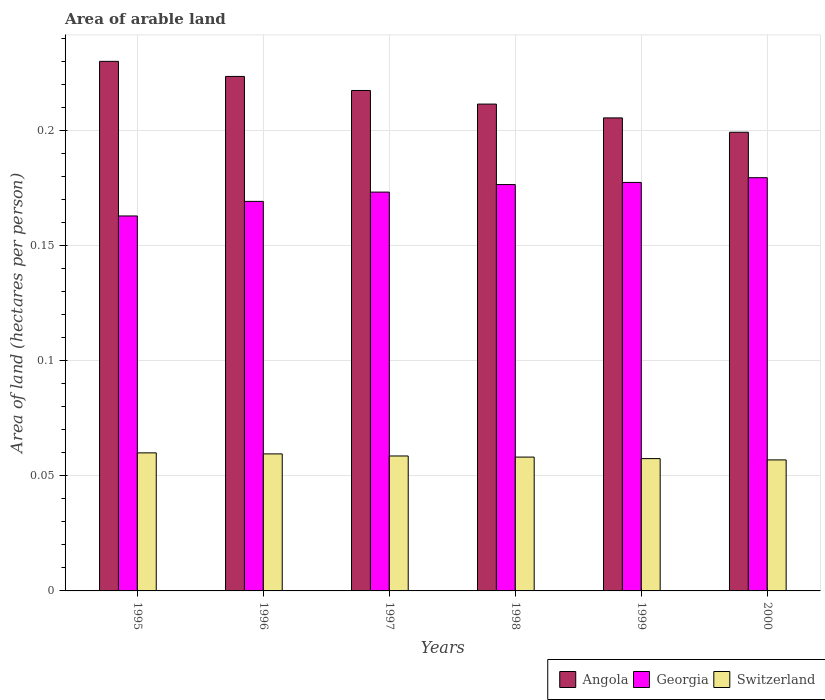How many different coloured bars are there?
Your response must be concise. 3. Are the number of bars on each tick of the X-axis equal?
Keep it short and to the point. Yes. How many bars are there on the 4th tick from the right?
Your answer should be very brief. 3. What is the label of the 1st group of bars from the left?
Offer a very short reply. 1995. What is the total arable land in Angola in 1996?
Offer a terse response. 0.22. Across all years, what is the maximum total arable land in Georgia?
Keep it short and to the point. 0.18. Across all years, what is the minimum total arable land in Angola?
Keep it short and to the point. 0.2. In which year was the total arable land in Switzerland maximum?
Your answer should be compact. 1995. In which year was the total arable land in Georgia minimum?
Make the answer very short. 1995. What is the total total arable land in Angola in the graph?
Give a very brief answer. 1.29. What is the difference between the total arable land in Angola in 1996 and that in 1997?
Make the answer very short. 0.01. What is the difference between the total arable land in Switzerland in 2000 and the total arable land in Angola in 1997?
Ensure brevity in your answer.  -0.16. What is the average total arable land in Switzerland per year?
Keep it short and to the point. 0.06. In the year 1997, what is the difference between the total arable land in Switzerland and total arable land in Georgia?
Your answer should be compact. -0.11. In how many years, is the total arable land in Angola greater than 0.2 hectares per person?
Offer a terse response. 5. What is the ratio of the total arable land in Angola in 1997 to that in 1999?
Give a very brief answer. 1.06. What is the difference between the highest and the second highest total arable land in Angola?
Give a very brief answer. 0.01. What is the difference between the highest and the lowest total arable land in Georgia?
Ensure brevity in your answer.  0.02. Is the sum of the total arable land in Angola in 1998 and 2000 greater than the maximum total arable land in Georgia across all years?
Give a very brief answer. Yes. What does the 3rd bar from the left in 1998 represents?
Provide a short and direct response. Switzerland. What does the 3rd bar from the right in 1998 represents?
Provide a succinct answer. Angola. Are all the bars in the graph horizontal?
Your response must be concise. No. How many years are there in the graph?
Offer a very short reply. 6. Does the graph contain any zero values?
Make the answer very short. No. Does the graph contain grids?
Keep it short and to the point. Yes. Where does the legend appear in the graph?
Offer a very short reply. Bottom right. What is the title of the graph?
Ensure brevity in your answer.  Area of arable land. Does "Curacao" appear as one of the legend labels in the graph?
Keep it short and to the point. No. What is the label or title of the Y-axis?
Your response must be concise. Area of land (hectares per person). What is the Area of land (hectares per person) in Angola in 1995?
Make the answer very short. 0.23. What is the Area of land (hectares per person) in Georgia in 1995?
Keep it short and to the point. 0.16. What is the Area of land (hectares per person) in Switzerland in 1995?
Make the answer very short. 0.06. What is the Area of land (hectares per person) of Angola in 1996?
Keep it short and to the point. 0.22. What is the Area of land (hectares per person) in Georgia in 1996?
Your answer should be compact. 0.17. What is the Area of land (hectares per person) in Switzerland in 1996?
Provide a short and direct response. 0.06. What is the Area of land (hectares per person) in Angola in 1997?
Ensure brevity in your answer.  0.22. What is the Area of land (hectares per person) in Georgia in 1997?
Offer a very short reply. 0.17. What is the Area of land (hectares per person) of Switzerland in 1997?
Provide a short and direct response. 0.06. What is the Area of land (hectares per person) of Angola in 1998?
Keep it short and to the point. 0.21. What is the Area of land (hectares per person) in Georgia in 1998?
Keep it short and to the point. 0.18. What is the Area of land (hectares per person) in Switzerland in 1998?
Make the answer very short. 0.06. What is the Area of land (hectares per person) in Angola in 1999?
Ensure brevity in your answer.  0.21. What is the Area of land (hectares per person) of Georgia in 1999?
Give a very brief answer. 0.18. What is the Area of land (hectares per person) of Switzerland in 1999?
Your answer should be very brief. 0.06. What is the Area of land (hectares per person) of Angola in 2000?
Offer a very short reply. 0.2. What is the Area of land (hectares per person) in Georgia in 2000?
Make the answer very short. 0.18. What is the Area of land (hectares per person) in Switzerland in 2000?
Offer a terse response. 0.06. Across all years, what is the maximum Area of land (hectares per person) of Angola?
Make the answer very short. 0.23. Across all years, what is the maximum Area of land (hectares per person) in Georgia?
Your answer should be very brief. 0.18. Across all years, what is the maximum Area of land (hectares per person) in Switzerland?
Make the answer very short. 0.06. Across all years, what is the minimum Area of land (hectares per person) of Angola?
Provide a succinct answer. 0.2. Across all years, what is the minimum Area of land (hectares per person) of Georgia?
Give a very brief answer. 0.16. Across all years, what is the minimum Area of land (hectares per person) in Switzerland?
Your answer should be very brief. 0.06. What is the total Area of land (hectares per person) in Angola in the graph?
Give a very brief answer. 1.29. What is the total Area of land (hectares per person) of Georgia in the graph?
Give a very brief answer. 1.04. What is the total Area of land (hectares per person) in Switzerland in the graph?
Your answer should be very brief. 0.35. What is the difference between the Area of land (hectares per person) in Angola in 1995 and that in 1996?
Give a very brief answer. 0.01. What is the difference between the Area of land (hectares per person) of Georgia in 1995 and that in 1996?
Provide a short and direct response. -0.01. What is the difference between the Area of land (hectares per person) of Switzerland in 1995 and that in 1996?
Make the answer very short. 0. What is the difference between the Area of land (hectares per person) of Angola in 1995 and that in 1997?
Keep it short and to the point. 0.01. What is the difference between the Area of land (hectares per person) in Georgia in 1995 and that in 1997?
Give a very brief answer. -0.01. What is the difference between the Area of land (hectares per person) in Switzerland in 1995 and that in 1997?
Your answer should be compact. 0. What is the difference between the Area of land (hectares per person) in Angola in 1995 and that in 1998?
Give a very brief answer. 0.02. What is the difference between the Area of land (hectares per person) of Georgia in 1995 and that in 1998?
Offer a terse response. -0.01. What is the difference between the Area of land (hectares per person) of Switzerland in 1995 and that in 1998?
Offer a terse response. 0. What is the difference between the Area of land (hectares per person) of Angola in 1995 and that in 1999?
Keep it short and to the point. 0.02. What is the difference between the Area of land (hectares per person) of Georgia in 1995 and that in 1999?
Make the answer very short. -0.01. What is the difference between the Area of land (hectares per person) of Switzerland in 1995 and that in 1999?
Your answer should be very brief. 0. What is the difference between the Area of land (hectares per person) in Angola in 1995 and that in 2000?
Ensure brevity in your answer.  0.03. What is the difference between the Area of land (hectares per person) of Georgia in 1995 and that in 2000?
Make the answer very short. -0.02. What is the difference between the Area of land (hectares per person) of Switzerland in 1995 and that in 2000?
Make the answer very short. 0. What is the difference between the Area of land (hectares per person) in Angola in 1996 and that in 1997?
Ensure brevity in your answer.  0.01. What is the difference between the Area of land (hectares per person) in Georgia in 1996 and that in 1997?
Offer a terse response. -0. What is the difference between the Area of land (hectares per person) in Switzerland in 1996 and that in 1997?
Offer a very short reply. 0. What is the difference between the Area of land (hectares per person) of Angola in 1996 and that in 1998?
Ensure brevity in your answer.  0.01. What is the difference between the Area of land (hectares per person) of Georgia in 1996 and that in 1998?
Your response must be concise. -0.01. What is the difference between the Area of land (hectares per person) of Switzerland in 1996 and that in 1998?
Make the answer very short. 0. What is the difference between the Area of land (hectares per person) in Angola in 1996 and that in 1999?
Your response must be concise. 0.02. What is the difference between the Area of land (hectares per person) of Georgia in 1996 and that in 1999?
Offer a terse response. -0.01. What is the difference between the Area of land (hectares per person) in Switzerland in 1996 and that in 1999?
Your response must be concise. 0. What is the difference between the Area of land (hectares per person) in Angola in 1996 and that in 2000?
Your response must be concise. 0.02. What is the difference between the Area of land (hectares per person) of Georgia in 1996 and that in 2000?
Provide a short and direct response. -0.01. What is the difference between the Area of land (hectares per person) in Switzerland in 1996 and that in 2000?
Give a very brief answer. 0. What is the difference between the Area of land (hectares per person) in Angola in 1997 and that in 1998?
Your response must be concise. 0.01. What is the difference between the Area of land (hectares per person) of Georgia in 1997 and that in 1998?
Provide a short and direct response. -0. What is the difference between the Area of land (hectares per person) in Angola in 1997 and that in 1999?
Your response must be concise. 0.01. What is the difference between the Area of land (hectares per person) of Georgia in 1997 and that in 1999?
Keep it short and to the point. -0. What is the difference between the Area of land (hectares per person) in Switzerland in 1997 and that in 1999?
Offer a terse response. 0. What is the difference between the Area of land (hectares per person) in Angola in 1997 and that in 2000?
Offer a very short reply. 0.02. What is the difference between the Area of land (hectares per person) in Georgia in 1997 and that in 2000?
Provide a succinct answer. -0.01. What is the difference between the Area of land (hectares per person) in Switzerland in 1997 and that in 2000?
Provide a short and direct response. 0. What is the difference between the Area of land (hectares per person) of Angola in 1998 and that in 1999?
Give a very brief answer. 0.01. What is the difference between the Area of land (hectares per person) in Georgia in 1998 and that in 1999?
Offer a very short reply. -0. What is the difference between the Area of land (hectares per person) in Switzerland in 1998 and that in 1999?
Your answer should be very brief. 0. What is the difference between the Area of land (hectares per person) in Angola in 1998 and that in 2000?
Your response must be concise. 0.01. What is the difference between the Area of land (hectares per person) in Georgia in 1998 and that in 2000?
Ensure brevity in your answer.  -0. What is the difference between the Area of land (hectares per person) in Switzerland in 1998 and that in 2000?
Give a very brief answer. 0. What is the difference between the Area of land (hectares per person) in Angola in 1999 and that in 2000?
Provide a succinct answer. 0.01. What is the difference between the Area of land (hectares per person) of Georgia in 1999 and that in 2000?
Provide a succinct answer. -0. What is the difference between the Area of land (hectares per person) in Switzerland in 1999 and that in 2000?
Offer a terse response. 0. What is the difference between the Area of land (hectares per person) in Angola in 1995 and the Area of land (hectares per person) in Georgia in 1996?
Offer a very short reply. 0.06. What is the difference between the Area of land (hectares per person) of Angola in 1995 and the Area of land (hectares per person) of Switzerland in 1996?
Make the answer very short. 0.17. What is the difference between the Area of land (hectares per person) of Georgia in 1995 and the Area of land (hectares per person) of Switzerland in 1996?
Give a very brief answer. 0.1. What is the difference between the Area of land (hectares per person) in Angola in 1995 and the Area of land (hectares per person) in Georgia in 1997?
Your response must be concise. 0.06. What is the difference between the Area of land (hectares per person) in Angola in 1995 and the Area of land (hectares per person) in Switzerland in 1997?
Ensure brevity in your answer.  0.17. What is the difference between the Area of land (hectares per person) in Georgia in 1995 and the Area of land (hectares per person) in Switzerland in 1997?
Ensure brevity in your answer.  0.1. What is the difference between the Area of land (hectares per person) of Angola in 1995 and the Area of land (hectares per person) of Georgia in 1998?
Provide a short and direct response. 0.05. What is the difference between the Area of land (hectares per person) in Angola in 1995 and the Area of land (hectares per person) in Switzerland in 1998?
Make the answer very short. 0.17. What is the difference between the Area of land (hectares per person) in Georgia in 1995 and the Area of land (hectares per person) in Switzerland in 1998?
Provide a short and direct response. 0.1. What is the difference between the Area of land (hectares per person) of Angola in 1995 and the Area of land (hectares per person) of Georgia in 1999?
Offer a terse response. 0.05. What is the difference between the Area of land (hectares per person) in Angola in 1995 and the Area of land (hectares per person) in Switzerland in 1999?
Your answer should be compact. 0.17. What is the difference between the Area of land (hectares per person) of Georgia in 1995 and the Area of land (hectares per person) of Switzerland in 1999?
Keep it short and to the point. 0.11. What is the difference between the Area of land (hectares per person) of Angola in 1995 and the Area of land (hectares per person) of Georgia in 2000?
Offer a very short reply. 0.05. What is the difference between the Area of land (hectares per person) in Angola in 1995 and the Area of land (hectares per person) in Switzerland in 2000?
Provide a succinct answer. 0.17. What is the difference between the Area of land (hectares per person) in Georgia in 1995 and the Area of land (hectares per person) in Switzerland in 2000?
Ensure brevity in your answer.  0.11. What is the difference between the Area of land (hectares per person) in Angola in 1996 and the Area of land (hectares per person) in Georgia in 1997?
Keep it short and to the point. 0.05. What is the difference between the Area of land (hectares per person) of Angola in 1996 and the Area of land (hectares per person) of Switzerland in 1997?
Keep it short and to the point. 0.16. What is the difference between the Area of land (hectares per person) in Georgia in 1996 and the Area of land (hectares per person) in Switzerland in 1997?
Keep it short and to the point. 0.11. What is the difference between the Area of land (hectares per person) in Angola in 1996 and the Area of land (hectares per person) in Georgia in 1998?
Provide a succinct answer. 0.05. What is the difference between the Area of land (hectares per person) in Angola in 1996 and the Area of land (hectares per person) in Switzerland in 1998?
Your answer should be compact. 0.17. What is the difference between the Area of land (hectares per person) in Georgia in 1996 and the Area of land (hectares per person) in Switzerland in 1998?
Your response must be concise. 0.11. What is the difference between the Area of land (hectares per person) of Angola in 1996 and the Area of land (hectares per person) of Georgia in 1999?
Keep it short and to the point. 0.05. What is the difference between the Area of land (hectares per person) in Angola in 1996 and the Area of land (hectares per person) in Switzerland in 1999?
Your response must be concise. 0.17. What is the difference between the Area of land (hectares per person) of Georgia in 1996 and the Area of land (hectares per person) of Switzerland in 1999?
Keep it short and to the point. 0.11. What is the difference between the Area of land (hectares per person) of Angola in 1996 and the Area of land (hectares per person) of Georgia in 2000?
Your answer should be compact. 0.04. What is the difference between the Area of land (hectares per person) in Angola in 1996 and the Area of land (hectares per person) in Switzerland in 2000?
Ensure brevity in your answer.  0.17. What is the difference between the Area of land (hectares per person) in Georgia in 1996 and the Area of land (hectares per person) in Switzerland in 2000?
Keep it short and to the point. 0.11. What is the difference between the Area of land (hectares per person) in Angola in 1997 and the Area of land (hectares per person) in Georgia in 1998?
Provide a short and direct response. 0.04. What is the difference between the Area of land (hectares per person) of Angola in 1997 and the Area of land (hectares per person) of Switzerland in 1998?
Keep it short and to the point. 0.16. What is the difference between the Area of land (hectares per person) in Georgia in 1997 and the Area of land (hectares per person) in Switzerland in 1998?
Your answer should be compact. 0.12. What is the difference between the Area of land (hectares per person) of Angola in 1997 and the Area of land (hectares per person) of Georgia in 1999?
Ensure brevity in your answer.  0.04. What is the difference between the Area of land (hectares per person) in Angola in 1997 and the Area of land (hectares per person) in Switzerland in 1999?
Provide a short and direct response. 0.16. What is the difference between the Area of land (hectares per person) of Georgia in 1997 and the Area of land (hectares per person) of Switzerland in 1999?
Make the answer very short. 0.12. What is the difference between the Area of land (hectares per person) in Angola in 1997 and the Area of land (hectares per person) in Georgia in 2000?
Ensure brevity in your answer.  0.04. What is the difference between the Area of land (hectares per person) in Angola in 1997 and the Area of land (hectares per person) in Switzerland in 2000?
Offer a very short reply. 0.16. What is the difference between the Area of land (hectares per person) of Georgia in 1997 and the Area of land (hectares per person) of Switzerland in 2000?
Offer a very short reply. 0.12. What is the difference between the Area of land (hectares per person) of Angola in 1998 and the Area of land (hectares per person) of Georgia in 1999?
Provide a short and direct response. 0.03. What is the difference between the Area of land (hectares per person) in Angola in 1998 and the Area of land (hectares per person) in Switzerland in 1999?
Ensure brevity in your answer.  0.15. What is the difference between the Area of land (hectares per person) in Georgia in 1998 and the Area of land (hectares per person) in Switzerland in 1999?
Ensure brevity in your answer.  0.12. What is the difference between the Area of land (hectares per person) in Angola in 1998 and the Area of land (hectares per person) in Georgia in 2000?
Provide a short and direct response. 0.03. What is the difference between the Area of land (hectares per person) of Angola in 1998 and the Area of land (hectares per person) of Switzerland in 2000?
Your response must be concise. 0.15. What is the difference between the Area of land (hectares per person) in Georgia in 1998 and the Area of land (hectares per person) in Switzerland in 2000?
Offer a very short reply. 0.12. What is the difference between the Area of land (hectares per person) in Angola in 1999 and the Area of land (hectares per person) in Georgia in 2000?
Ensure brevity in your answer.  0.03. What is the difference between the Area of land (hectares per person) in Angola in 1999 and the Area of land (hectares per person) in Switzerland in 2000?
Your answer should be very brief. 0.15. What is the difference between the Area of land (hectares per person) of Georgia in 1999 and the Area of land (hectares per person) of Switzerland in 2000?
Your answer should be compact. 0.12. What is the average Area of land (hectares per person) of Angola per year?
Provide a short and direct response. 0.21. What is the average Area of land (hectares per person) of Georgia per year?
Make the answer very short. 0.17. What is the average Area of land (hectares per person) in Switzerland per year?
Your response must be concise. 0.06. In the year 1995, what is the difference between the Area of land (hectares per person) of Angola and Area of land (hectares per person) of Georgia?
Keep it short and to the point. 0.07. In the year 1995, what is the difference between the Area of land (hectares per person) in Angola and Area of land (hectares per person) in Switzerland?
Your answer should be compact. 0.17. In the year 1995, what is the difference between the Area of land (hectares per person) in Georgia and Area of land (hectares per person) in Switzerland?
Offer a very short reply. 0.1. In the year 1996, what is the difference between the Area of land (hectares per person) in Angola and Area of land (hectares per person) in Georgia?
Keep it short and to the point. 0.05. In the year 1996, what is the difference between the Area of land (hectares per person) of Angola and Area of land (hectares per person) of Switzerland?
Offer a terse response. 0.16. In the year 1996, what is the difference between the Area of land (hectares per person) of Georgia and Area of land (hectares per person) of Switzerland?
Keep it short and to the point. 0.11. In the year 1997, what is the difference between the Area of land (hectares per person) of Angola and Area of land (hectares per person) of Georgia?
Your answer should be very brief. 0.04. In the year 1997, what is the difference between the Area of land (hectares per person) in Angola and Area of land (hectares per person) in Switzerland?
Your response must be concise. 0.16. In the year 1997, what is the difference between the Area of land (hectares per person) in Georgia and Area of land (hectares per person) in Switzerland?
Offer a terse response. 0.11. In the year 1998, what is the difference between the Area of land (hectares per person) of Angola and Area of land (hectares per person) of Georgia?
Keep it short and to the point. 0.04. In the year 1998, what is the difference between the Area of land (hectares per person) in Angola and Area of land (hectares per person) in Switzerland?
Provide a succinct answer. 0.15. In the year 1998, what is the difference between the Area of land (hectares per person) in Georgia and Area of land (hectares per person) in Switzerland?
Give a very brief answer. 0.12. In the year 1999, what is the difference between the Area of land (hectares per person) of Angola and Area of land (hectares per person) of Georgia?
Provide a short and direct response. 0.03. In the year 1999, what is the difference between the Area of land (hectares per person) of Angola and Area of land (hectares per person) of Switzerland?
Ensure brevity in your answer.  0.15. In the year 1999, what is the difference between the Area of land (hectares per person) of Georgia and Area of land (hectares per person) of Switzerland?
Your answer should be very brief. 0.12. In the year 2000, what is the difference between the Area of land (hectares per person) of Angola and Area of land (hectares per person) of Georgia?
Offer a very short reply. 0.02. In the year 2000, what is the difference between the Area of land (hectares per person) of Angola and Area of land (hectares per person) of Switzerland?
Your response must be concise. 0.14. In the year 2000, what is the difference between the Area of land (hectares per person) of Georgia and Area of land (hectares per person) of Switzerland?
Provide a succinct answer. 0.12. What is the ratio of the Area of land (hectares per person) of Angola in 1995 to that in 1996?
Provide a succinct answer. 1.03. What is the ratio of the Area of land (hectares per person) in Georgia in 1995 to that in 1996?
Provide a succinct answer. 0.96. What is the ratio of the Area of land (hectares per person) of Switzerland in 1995 to that in 1996?
Your answer should be very brief. 1.01. What is the ratio of the Area of land (hectares per person) of Angola in 1995 to that in 1997?
Give a very brief answer. 1.06. What is the ratio of the Area of land (hectares per person) in Georgia in 1995 to that in 1997?
Your answer should be compact. 0.94. What is the ratio of the Area of land (hectares per person) of Switzerland in 1995 to that in 1997?
Keep it short and to the point. 1.02. What is the ratio of the Area of land (hectares per person) in Angola in 1995 to that in 1998?
Provide a succinct answer. 1.09. What is the ratio of the Area of land (hectares per person) of Georgia in 1995 to that in 1998?
Make the answer very short. 0.92. What is the ratio of the Area of land (hectares per person) in Switzerland in 1995 to that in 1998?
Your response must be concise. 1.03. What is the ratio of the Area of land (hectares per person) of Angola in 1995 to that in 1999?
Offer a very short reply. 1.12. What is the ratio of the Area of land (hectares per person) of Georgia in 1995 to that in 1999?
Ensure brevity in your answer.  0.92. What is the ratio of the Area of land (hectares per person) of Switzerland in 1995 to that in 1999?
Keep it short and to the point. 1.04. What is the ratio of the Area of land (hectares per person) of Angola in 1995 to that in 2000?
Offer a terse response. 1.15. What is the ratio of the Area of land (hectares per person) of Georgia in 1995 to that in 2000?
Keep it short and to the point. 0.91. What is the ratio of the Area of land (hectares per person) in Switzerland in 1995 to that in 2000?
Provide a short and direct response. 1.05. What is the ratio of the Area of land (hectares per person) of Angola in 1996 to that in 1997?
Provide a succinct answer. 1.03. What is the ratio of the Area of land (hectares per person) in Georgia in 1996 to that in 1997?
Ensure brevity in your answer.  0.98. What is the ratio of the Area of land (hectares per person) of Switzerland in 1996 to that in 1997?
Keep it short and to the point. 1.02. What is the ratio of the Area of land (hectares per person) of Angola in 1996 to that in 1998?
Keep it short and to the point. 1.06. What is the ratio of the Area of land (hectares per person) in Georgia in 1996 to that in 1998?
Give a very brief answer. 0.96. What is the ratio of the Area of land (hectares per person) of Switzerland in 1996 to that in 1998?
Ensure brevity in your answer.  1.02. What is the ratio of the Area of land (hectares per person) in Angola in 1996 to that in 1999?
Keep it short and to the point. 1.09. What is the ratio of the Area of land (hectares per person) of Georgia in 1996 to that in 1999?
Offer a very short reply. 0.95. What is the ratio of the Area of land (hectares per person) in Switzerland in 1996 to that in 1999?
Give a very brief answer. 1.04. What is the ratio of the Area of land (hectares per person) in Angola in 1996 to that in 2000?
Your answer should be compact. 1.12. What is the ratio of the Area of land (hectares per person) in Georgia in 1996 to that in 2000?
Keep it short and to the point. 0.94. What is the ratio of the Area of land (hectares per person) of Switzerland in 1996 to that in 2000?
Offer a very short reply. 1.05. What is the ratio of the Area of land (hectares per person) in Angola in 1997 to that in 1998?
Your answer should be very brief. 1.03. What is the ratio of the Area of land (hectares per person) in Georgia in 1997 to that in 1998?
Give a very brief answer. 0.98. What is the ratio of the Area of land (hectares per person) in Switzerland in 1997 to that in 1998?
Make the answer very short. 1.01. What is the ratio of the Area of land (hectares per person) of Angola in 1997 to that in 1999?
Provide a succinct answer. 1.06. What is the ratio of the Area of land (hectares per person) in Georgia in 1997 to that in 1999?
Make the answer very short. 0.98. What is the ratio of the Area of land (hectares per person) in Switzerland in 1997 to that in 1999?
Offer a terse response. 1.02. What is the ratio of the Area of land (hectares per person) in Angola in 1997 to that in 2000?
Give a very brief answer. 1.09. What is the ratio of the Area of land (hectares per person) in Georgia in 1997 to that in 2000?
Provide a short and direct response. 0.97. What is the ratio of the Area of land (hectares per person) in Switzerland in 1997 to that in 2000?
Your answer should be very brief. 1.03. What is the ratio of the Area of land (hectares per person) in Angola in 1998 to that in 1999?
Your response must be concise. 1.03. What is the ratio of the Area of land (hectares per person) in Switzerland in 1998 to that in 1999?
Give a very brief answer. 1.01. What is the ratio of the Area of land (hectares per person) of Angola in 1998 to that in 2000?
Offer a very short reply. 1.06. What is the ratio of the Area of land (hectares per person) of Georgia in 1998 to that in 2000?
Provide a succinct answer. 0.98. What is the ratio of the Area of land (hectares per person) in Switzerland in 1998 to that in 2000?
Your answer should be compact. 1.02. What is the ratio of the Area of land (hectares per person) of Angola in 1999 to that in 2000?
Offer a terse response. 1.03. What is the ratio of the Area of land (hectares per person) in Switzerland in 1999 to that in 2000?
Provide a short and direct response. 1.01. What is the difference between the highest and the second highest Area of land (hectares per person) in Angola?
Ensure brevity in your answer.  0.01. What is the difference between the highest and the second highest Area of land (hectares per person) of Georgia?
Offer a very short reply. 0. What is the difference between the highest and the second highest Area of land (hectares per person) of Switzerland?
Keep it short and to the point. 0. What is the difference between the highest and the lowest Area of land (hectares per person) of Angola?
Provide a short and direct response. 0.03. What is the difference between the highest and the lowest Area of land (hectares per person) in Georgia?
Your response must be concise. 0.02. What is the difference between the highest and the lowest Area of land (hectares per person) in Switzerland?
Your response must be concise. 0. 